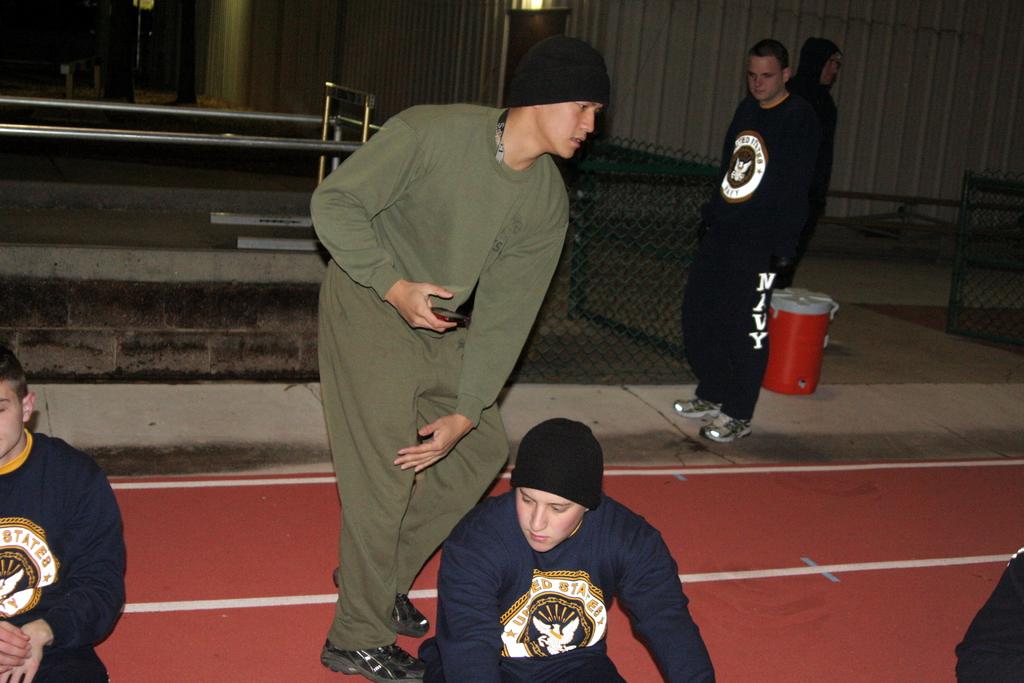What is written on the black pants worn by the guy at the back?
Provide a short and direct response. Navy. What is on the back guys pants?
Make the answer very short. Navy. 